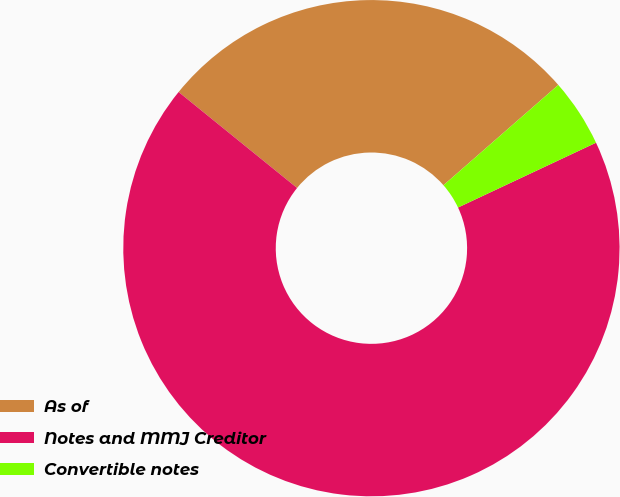Convert chart. <chart><loc_0><loc_0><loc_500><loc_500><pie_chart><fcel>As of<fcel>Notes and MMJ Creditor<fcel>Convertible notes<nl><fcel>27.74%<fcel>67.83%<fcel>4.44%<nl></chart> 